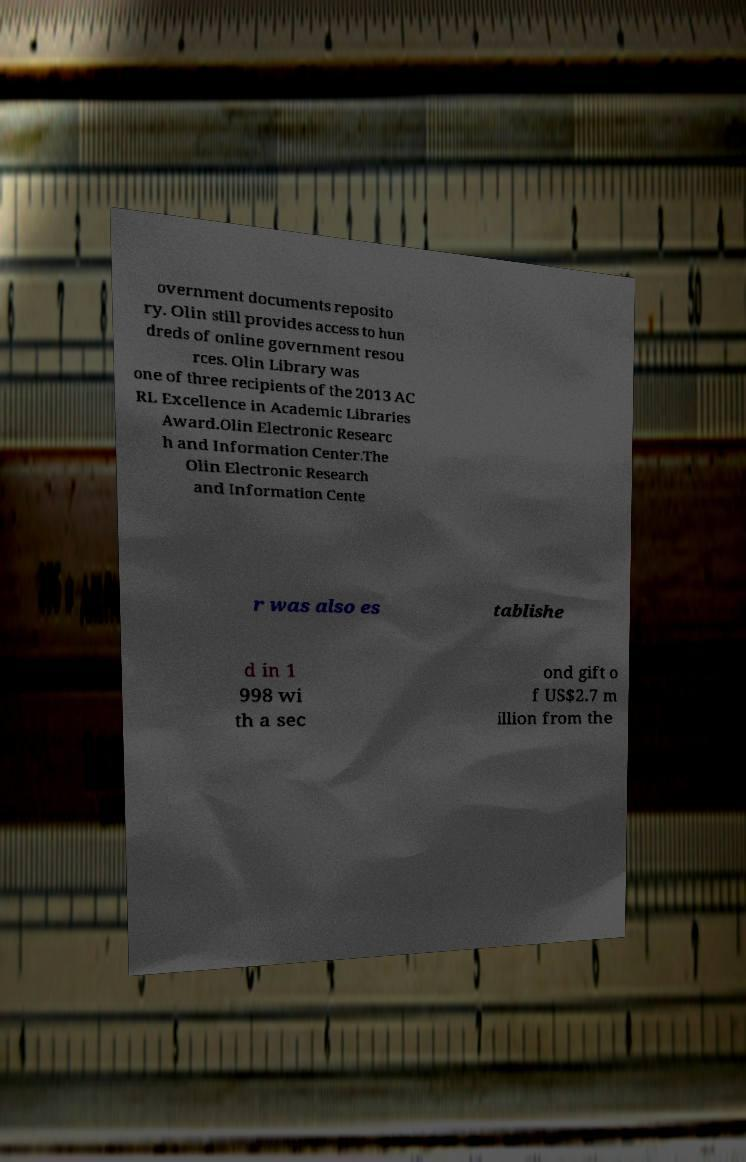I need the written content from this picture converted into text. Can you do that? overnment documents reposito ry. Olin still provides access to hun dreds of online government resou rces. Olin Library was one of three recipients of the 2013 AC RL Excellence in Academic Libraries Award.Olin Electronic Researc h and Information Center.The Olin Electronic Research and Information Cente r was also es tablishe d in 1 998 wi th a sec ond gift o f US$2.7 m illion from the 